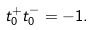<formula> <loc_0><loc_0><loc_500><loc_500>t _ { 0 } ^ { + } t _ { 0 } ^ { - } = - 1 .</formula> 